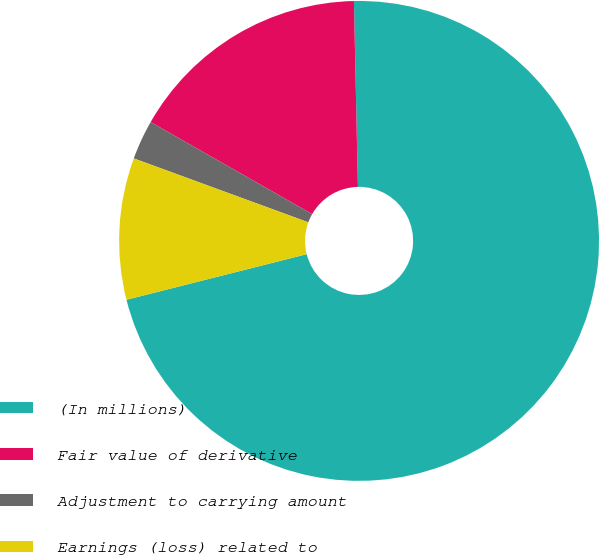Convert chart to OTSL. <chart><loc_0><loc_0><loc_500><loc_500><pie_chart><fcel>(In millions)<fcel>Fair value of derivative<fcel>Adjustment to carrying amount<fcel>Earnings (loss) related to<nl><fcel>71.4%<fcel>16.41%<fcel>2.66%<fcel>9.53%<nl></chart> 